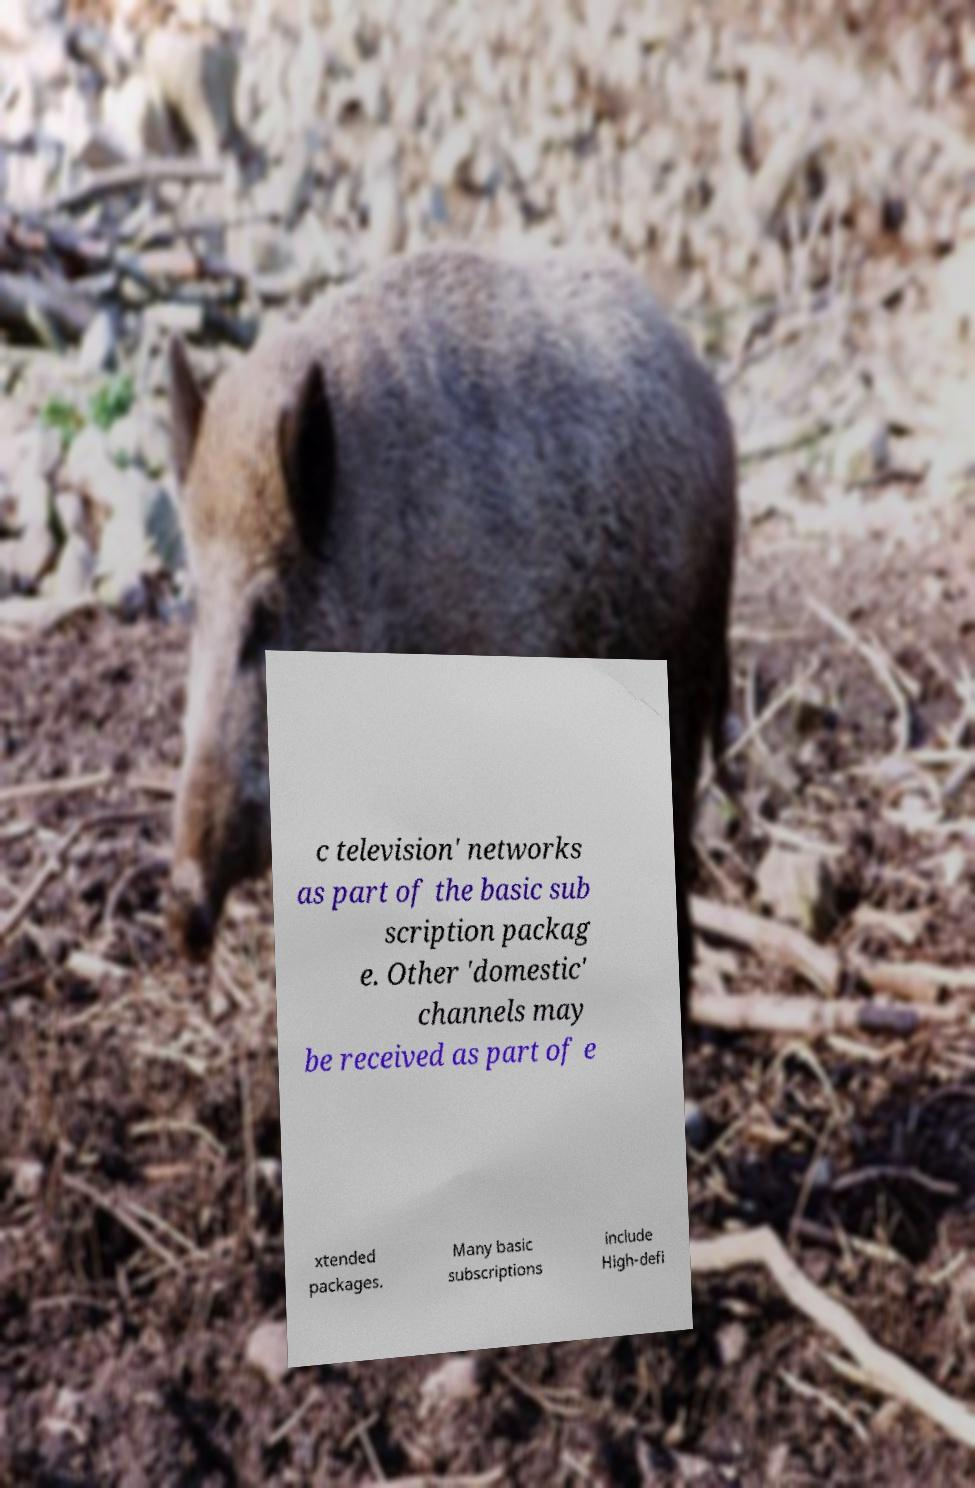Please read and relay the text visible in this image. What does it say? c television' networks as part of the basic sub scription packag e. Other 'domestic' channels may be received as part of e xtended packages. Many basic subscriptions include High-defi 